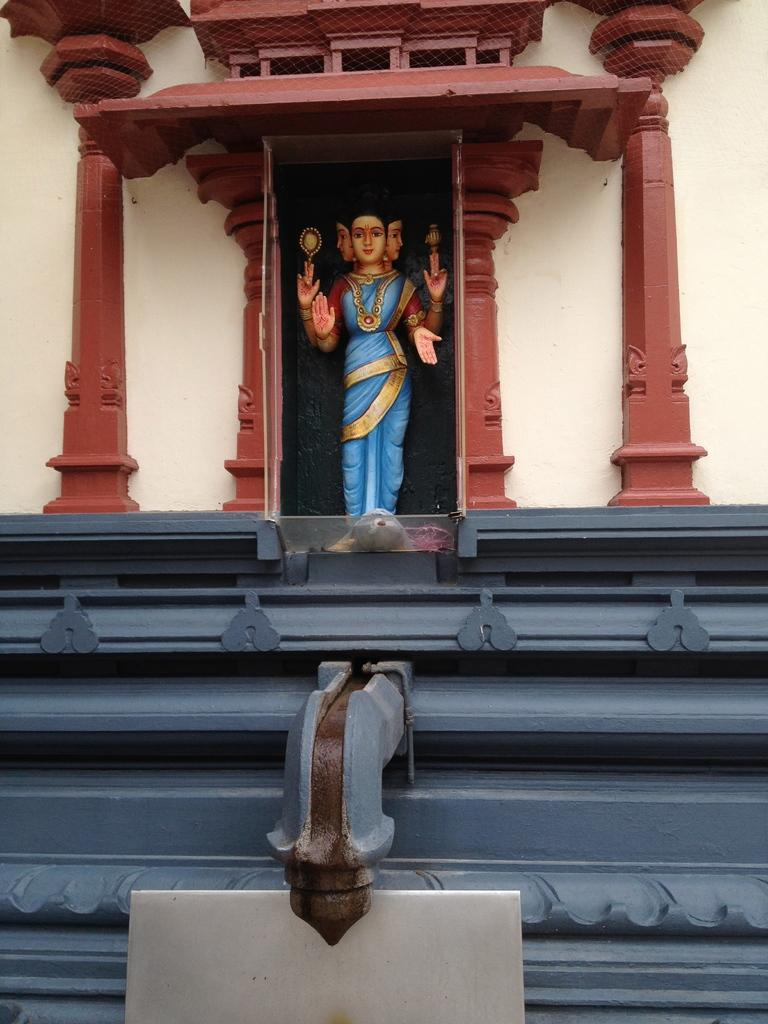What is the main subject of the image? There is a statue in the image. Where is the statue located? The statue is on a platform. What else can be seen in the image? There is a wall in the image. Are there any other objects present in the image? Yes, there are objects present in the image. What type of wood is used to make the children's toys in the image? There are no children or toys present in the image, so it is not possible to determine the type of wood used for any toys. 